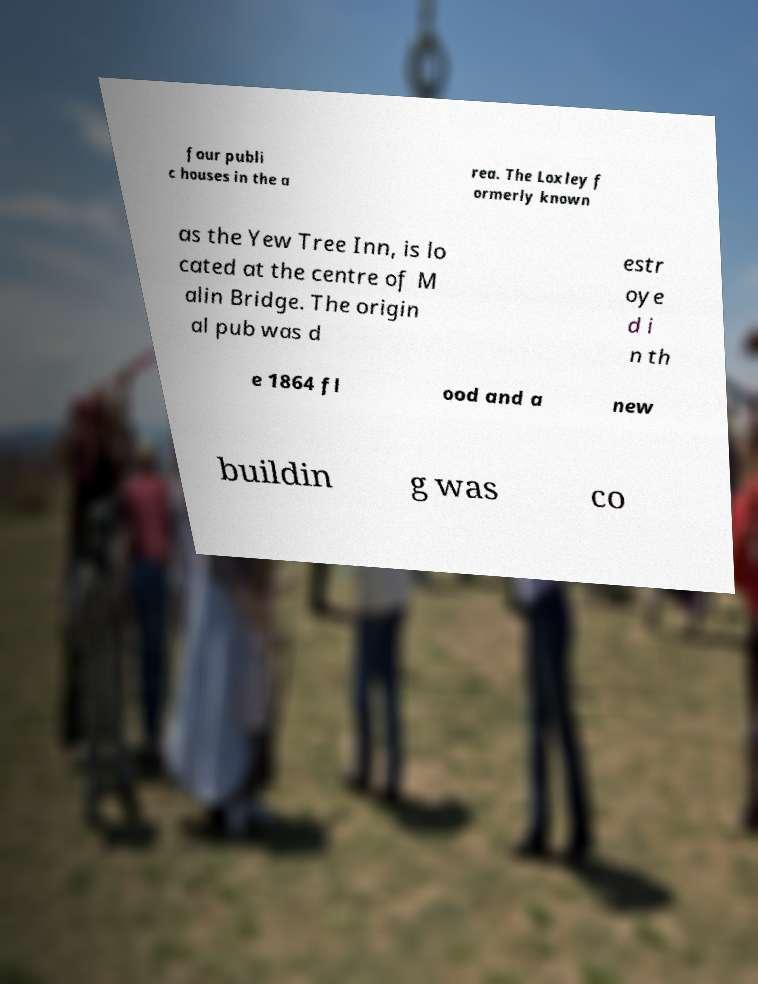Could you assist in decoding the text presented in this image and type it out clearly? four publi c houses in the a rea. The Loxley f ormerly known as the Yew Tree Inn, is lo cated at the centre of M alin Bridge. The origin al pub was d estr oye d i n th e 1864 fl ood and a new buildin g was co 